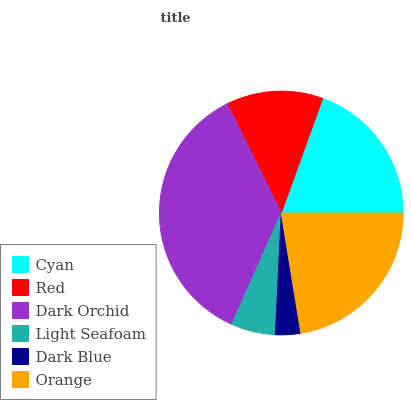Is Dark Blue the minimum?
Answer yes or no. Yes. Is Dark Orchid the maximum?
Answer yes or no. Yes. Is Red the minimum?
Answer yes or no. No. Is Red the maximum?
Answer yes or no. No. Is Cyan greater than Red?
Answer yes or no. Yes. Is Red less than Cyan?
Answer yes or no. Yes. Is Red greater than Cyan?
Answer yes or no. No. Is Cyan less than Red?
Answer yes or no. No. Is Cyan the high median?
Answer yes or no. Yes. Is Red the low median?
Answer yes or no. Yes. Is Dark Blue the high median?
Answer yes or no. No. Is Cyan the low median?
Answer yes or no. No. 